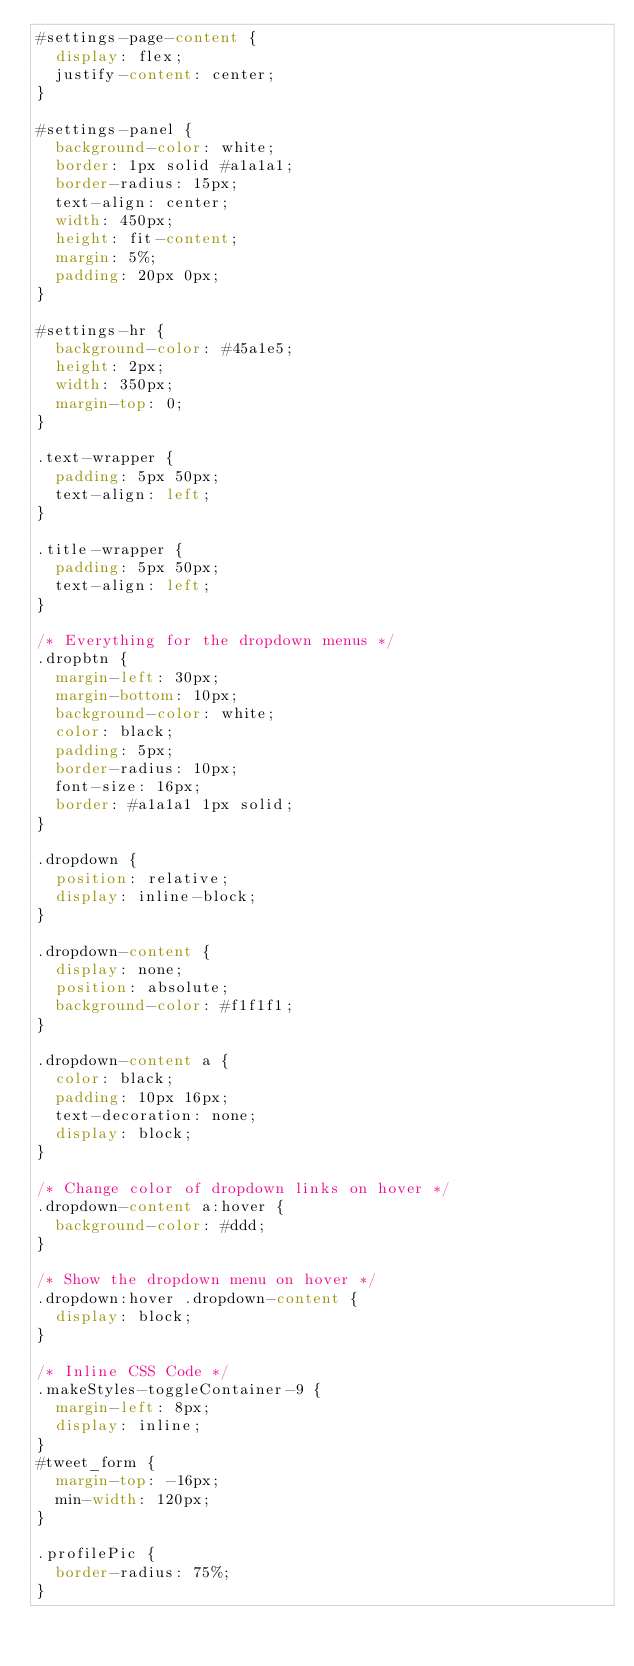<code> <loc_0><loc_0><loc_500><loc_500><_CSS_>#settings-page-content {
  display: flex;
  justify-content: center;
}

#settings-panel {
  background-color: white;
  border: 1px solid #a1a1a1;
  border-radius: 15px;
  text-align: center;
  width: 450px;
  height: fit-content;
  margin: 5%;
  padding: 20px 0px;
}

#settings-hr {
  background-color: #45a1e5;
  height: 2px;
  width: 350px;
  margin-top: 0;
}

.text-wrapper {
  padding: 5px 50px;
  text-align: left;
}

.title-wrapper {
  padding: 5px 50px;
  text-align: left;
}

/* Everything for the dropdown menus */
.dropbtn {
  margin-left: 30px;
  margin-bottom: 10px;
  background-color: white;
  color: black;
  padding: 5px;
  border-radius: 10px;
  font-size: 16px;
  border: #a1a1a1 1px solid;
}

.dropdown {
  position: relative;
  display: inline-block;
}

.dropdown-content {
  display: none;
  position: absolute;
  background-color: #f1f1f1;
}

.dropdown-content a {
  color: black;
  padding: 10px 16px;
  text-decoration: none;
  display: block;
}

/* Change color of dropdown links on hover */
.dropdown-content a:hover {
  background-color: #ddd;
}

/* Show the dropdown menu on hover */
.dropdown:hover .dropdown-content {
  display: block;
}

/* Inline CSS Code */
.makeStyles-toggleContainer-9 {
  margin-left: 8px;
  display: inline;
}
#tweet_form {
  margin-top: -16px;
  min-width: 120px;
}

.profilePic {
  border-radius: 75%;
}
</code> 